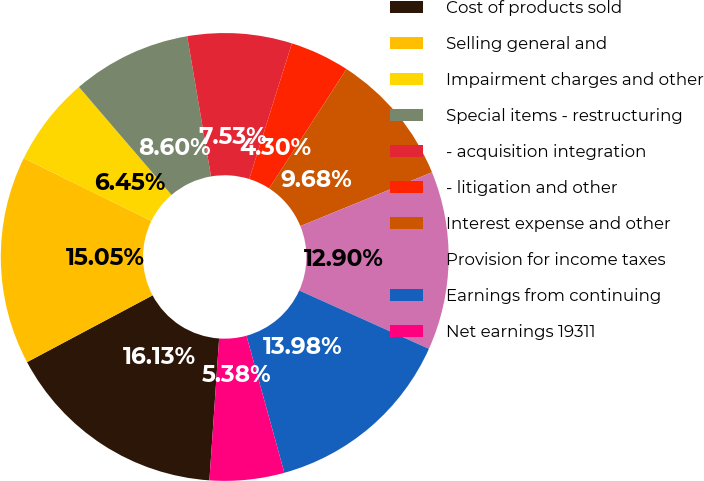<chart> <loc_0><loc_0><loc_500><loc_500><pie_chart><fcel>Cost of products sold<fcel>Selling general and<fcel>Impairment charges and other<fcel>Special items - restructuring<fcel>- acquisition integration<fcel>- litigation and other<fcel>Interest expense and other<fcel>Provision for income taxes<fcel>Earnings from continuing<fcel>Net earnings 19311<nl><fcel>16.13%<fcel>15.05%<fcel>6.45%<fcel>8.6%<fcel>7.53%<fcel>4.3%<fcel>9.68%<fcel>12.9%<fcel>13.98%<fcel>5.38%<nl></chart> 